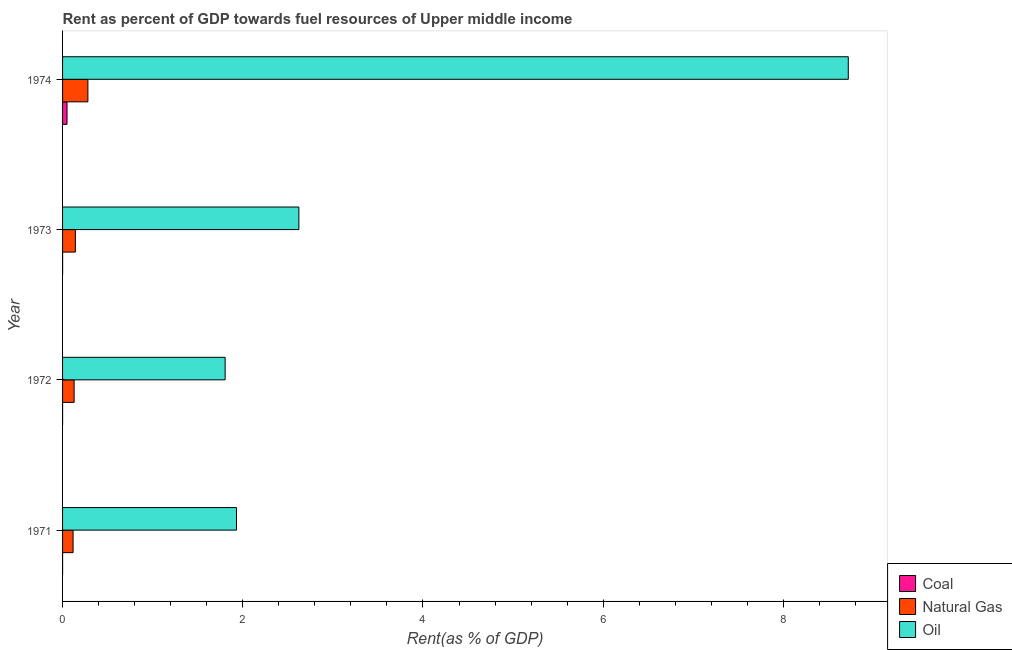How many different coloured bars are there?
Your answer should be very brief. 3. How many groups of bars are there?
Keep it short and to the point. 4. Are the number of bars on each tick of the Y-axis equal?
Provide a succinct answer. Yes. How many bars are there on the 2nd tick from the top?
Provide a short and direct response. 3. How many bars are there on the 4th tick from the bottom?
Offer a terse response. 3. What is the rent towards natural gas in 1974?
Make the answer very short. 0.28. Across all years, what is the maximum rent towards natural gas?
Your answer should be very brief. 0.28. Across all years, what is the minimum rent towards natural gas?
Make the answer very short. 0.12. In which year was the rent towards coal maximum?
Keep it short and to the point. 1974. What is the total rent towards natural gas in the graph?
Your response must be concise. 0.67. What is the difference between the rent towards oil in 1972 and that in 1974?
Give a very brief answer. -6.92. What is the difference between the rent towards oil in 1974 and the rent towards natural gas in 1973?
Your response must be concise. 8.58. What is the average rent towards oil per year?
Provide a short and direct response. 3.77. In the year 1972, what is the difference between the rent towards natural gas and rent towards oil?
Offer a very short reply. -1.68. What is the ratio of the rent towards oil in 1971 to that in 1974?
Your response must be concise. 0.22. Is the rent towards coal in 1972 less than that in 1973?
Give a very brief answer. Yes. Is the difference between the rent towards coal in 1971 and 1972 greater than the difference between the rent towards oil in 1971 and 1972?
Make the answer very short. No. What is the difference between the highest and the second highest rent towards coal?
Keep it short and to the point. 0.05. What is the difference between the highest and the lowest rent towards coal?
Your answer should be compact. 0.05. In how many years, is the rent towards natural gas greater than the average rent towards natural gas taken over all years?
Give a very brief answer. 1. What does the 3rd bar from the top in 1972 represents?
Offer a terse response. Coal. What does the 1st bar from the bottom in 1971 represents?
Your response must be concise. Coal. How many years are there in the graph?
Provide a succinct answer. 4. What is the difference between two consecutive major ticks on the X-axis?
Ensure brevity in your answer.  2. Does the graph contain grids?
Provide a succinct answer. No. Where does the legend appear in the graph?
Provide a short and direct response. Bottom right. How many legend labels are there?
Ensure brevity in your answer.  3. How are the legend labels stacked?
Make the answer very short. Vertical. What is the title of the graph?
Keep it short and to the point. Rent as percent of GDP towards fuel resources of Upper middle income. What is the label or title of the X-axis?
Ensure brevity in your answer.  Rent(as % of GDP). What is the label or title of the Y-axis?
Ensure brevity in your answer.  Year. What is the Rent(as % of GDP) in Coal in 1971?
Your response must be concise. 0. What is the Rent(as % of GDP) of Natural Gas in 1971?
Ensure brevity in your answer.  0.12. What is the Rent(as % of GDP) in Oil in 1971?
Your answer should be very brief. 1.93. What is the Rent(as % of GDP) of Coal in 1972?
Keep it short and to the point. 0. What is the Rent(as % of GDP) in Natural Gas in 1972?
Your response must be concise. 0.13. What is the Rent(as % of GDP) in Oil in 1972?
Your answer should be very brief. 1.8. What is the Rent(as % of GDP) in Coal in 1973?
Provide a short and direct response. 0. What is the Rent(as % of GDP) in Natural Gas in 1973?
Provide a short and direct response. 0.14. What is the Rent(as % of GDP) in Oil in 1973?
Offer a terse response. 2.62. What is the Rent(as % of GDP) of Coal in 1974?
Your response must be concise. 0.05. What is the Rent(as % of GDP) of Natural Gas in 1974?
Provide a succinct answer. 0.28. What is the Rent(as % of GDP) of Oil in 1974?
Your answer should be very brief. 8.72. Across all years, what is the maximum Rent(as % of GDP) in Coal?
Ensure brevity in your answer.  0.05. Across all years, what is the maximum Rent(as % of GDP) of Natural Gas?
Keep it short and to the point. 0.28. Across all years, what is the maximum Rent(as % of GDP) of Oil?
Make the answer very short. 8.72. Across all years, what is the minimum Rent(as % of GDP) in Coal?
Your answer should be compact. 0. Across all years, what is the minimum Rent(as % of GDP) of Natural Gas?
Offer a very short reply. 0.12. Across all years, what is the minimum Rent(as % of GDP) of Oil?
Keep it short and to the point. 1.8. What is the total Rent(as % of GDP) in Coal in the graph?
Offer a terse response. 0.05. What is the total Rent(as % of GDP) in Natural Gas in the graph?
Your answer should be compact. 0.67. What is the total Rent(as % of GDP) of Oil in the graph?
Offer a terse response. 15.08. What is the difference between the Rent(as % of GDP) in Coal in 1971 and that in 1972?
Provide a succinct answer. -0. What is the difference between the Rent(as % of GDP) of Natural Gas in 1971 and that in 1972?
Provide a succinct answer. -0.01. What is the difference between the Rent(as % of GDP) of Oil in 1971 and that in 1972?
Your answer should be very brief. 0.13. What is the difference between the Rent(as % of GDP) in Coal in 1971 and that in 1973?
Your response must be concise. -0. What is the difference between the Rent(as % of GDP) in Natural Gas in 1971 and that in 1973?
Your answer should be very brief. -0.03. What is the difference between the Rent(as % of GDP) of Oil in 1971 and that in 1973?
Provide a succinct answer. -0.69. What is the difference between the Rent(as % of GDP) of Coal in 1971 and that in 1974?
Offer a terse response. -0.05. What is the difference between the Rent(as % of GDP) of Natural Gas in 1971 and that in 1974?
Your answer should be compact. -0.16. What is the difference between the Rent(as % of GDP) of Oil in 1971 and that in 1974?
Provide a short and direct response. -6.79. What is the difference between the Rent(as % of GDP) of Coal in 1972 and that in 1973?
Offer a terse response. -0. What is the difference between the Rent(as % of GDP) in Natural Gas in 1972 and that in 1973?
Provide a succinct answer. -0.01. What is the difference between the Rent(as % of GDP) in Oil in 1972 and that in 1973?
Offer a terse response. -0.82. What is the difference between the Rent(as % of GDP) in Coal in 1972 and that in 1974?
Your response must be concise. -0.05. What is the difference between the Rent(as % of GDP) in Natural Gas in 1972 and that in 1974?
Ensure brevity in your answer.  -0.15. What is the difference between the Rent(as % of GDP) of Oil in 1972 and that in 1974?
Provide a succinct answer. -6.92. What is the difference between the Rent(as % of GDP) in Coal in 1973 and that in 1974?
Make the answer very short. -0.05. What is the difference between the Rent(as % of GDP) of Natural Gas in 1973 and that in 1974?
Ensure brevity in your answer.  -0.14. What is the difference between the Rent(as % of GDP) in Oil in 1973 and that in 1974?
Ensure brevity in your answer.  -6.1. What is the difference between the Rent(as % of GDP) of Coal in 1971 and the Rent(as % of GDP) of Natural Gas in 1972?
Provide a short and direct response. -0.13. What is the difference between the Rent(as % of GDP) of Coal in 1971 and the Rent(as % of GDP) of Oil in 1972?
Your answer should be very brief. -1.8. What is the difference between the Rent(as % of GDP) in Natural Gas in 1971 and the Rent(as % of GDP) in Oil in 1972?
Your answer should be compact. -1.69. What is the difference between the Rent(as % of GDP) of Coal in 1971 and the Rent(as % of GDP) of Natural Gas in 1973?
Make the answer very short. -0.14. What is the difference between the Rent(as % of GDP) in Coal in 1971 and the Rent(as % of GDP) in Oil in 1973?
Offer a terse response. -2.62. What is the difference between the Rent(as % of GDP) in Natural Gas in 1971 and the Rent(as % of GDP) in Oil in 1973?
Your response must be concise. -2.51. What is the difference between the Rent(as % of GDP) in Coal in 1971 and the Rent(as % of GDP) in Natural Gas in 1974?
Your answer should be compact. -0.28. What is the difference between the Rent(as % of GDP) of Coal in 1971 and the Rent(as % of GDP) of Oil in 1974?
Ensure brevity in your answer.  -8.72. What is the difference between the Rent(as % of GDP) of Natural Gas in 1971 and the Rent(as % of GDP) of Oil in 1974?
Give a very brief answer. -8.6. What is the difference between the Rent(as % of GDP) of Coal in 1972 and the Rent(as % of GDP) of Natural Gas in 1973?
Your answer should be compact. -0.14. What is the difference between the Rent(as % of GDP) in Coal in 1972 and the Rent(as % of GDP) in Oil in 1973?
Make the answer very short. -2.62. What is the difference between the Rent(as % of GDP) of Natural Gas in 1972 and the Rent(as % of GDP) of Oil in 1973?
Provide a short and direct response. -2.49. What is the difference between the Rent(as % of GDP) of Coal in 1972 and the Rent(as % of GDP) of Natural Gas in 1974?
Provide a short and direct response. -0.28. What is the difference between the Rent(as % of GDP) in Coal in 1972 and the Rent(as % of GDP) in Oil in 1974?
Provide a succinct answer. -8.72. What is the difference between the Rent(as % of GDP) of Natural Gas in 1972 and the Rent(as % of GDP) of Oil in 1974?
Give a very brief answer. -8.59. What is the difference between the Rent(as % of GDP) in Coal in 1973 and the Rent(as % of GDP) in Natural Gas in 1974?
Your answer should be compact. -0.28. What is the difference between the Rent(as % of GDP) in Coal in 1973 and the Rent(as % of GDP) in Oil in 1974?
Your answer should be very brief. -8.72. What is the difference between the Rent(as % of GDP) in Natural Gas in 1973 and the Rent(as % of GDP) in Oil in 1974?
Offer a terse response. -8.58. What is the average Rent(as % of GDP) of Coal per year?
Your response must be concise. 0.01. What is the average Rent(as % of GDP) of Natural Gas per year?
Make the answer very short. 0.17. What is the average Rent(as % of GDP) in Oil per year?
Provide a succinct answer. 3.77. In the year 1971, what is the difference between the Rent(as % of GDP) of Coal and Rent(as % of GDP) of Natural Gas?
Provide a succinct answer. -0.12. In the year 1971, what is the difference between the Rent(as % of GDP) in Coal and Rent(as % of GDP) in Oil?
Provide a succinct answer. -1.93. In the year 1971, what is the difference between the Rent(as % of GDP) of Natural Gas and Rent(as % of GDP) of Oil?
Your response must be concise. -1.81. In the year 1972, what is the difference between the Rent(as % of GDP) of Coal and Rent(as % of GDP) of Natural Gas?
Provide a short and direct response. -0.13. In the year 1972, what is the difference between the Rent(as % of GDP) in Coal and Rent(as % of GDP) in Oil?
Provide a succinct answer. -1.8. In the year 1972, what is the difference between the Rent(as % of GDP) of Natural Gas and Rent(as % of GDP) of Oil?
Offer a very short reply. -1.68. In the year 1973, what is the difference between the Rent(as % of GDP) of Coal and Rent(as % of GDP) of Natural Gas?
Make the answer very short. -0.14. In the year 1973, what is the difference between the Rent(as % of GDP) in Coal and Rent(as % of GDP) in Oil?
Provide a short and direct response. -2.62. In the year 1973, what is the difference between the Rent(as % of GDP) of Natural Gas and Rent(as % of GDP) of Oil?
Keep it short and to the point. -2.48. In the year 1974, what is the difference between the Rent(as % of GDP) in Coal and Rent(as % of GDP) in Natural Gas?
Keep it short and to the point. -0.23. In the year 1974, what is the difference between the Rent(as % of GDP) in Coal and Rent(as % of GDP) in Oil?
Your response must be concise. -8.67. In the year 1974, what is the difference between the Rent(as % of GDP) of Natural Gas and Rent(as % of GDP) of Oil?
Offer a very short reply. -8.44. What is the ratio of the Rent(as % of GDP) of Coal in 1971 to that in 1972?
Your response must be concise. 0.77. What is the ratio of the Rent(as % of GDP) of Natural Gas in 1971 to that in 1972?
Your answer should be compact. 0.91. What is the ratio of the Rent(as % of GDP) in Oil in 1971 to that in 1972?
Give a very brief answer. 1.07. What is the ratio of the Rent(as % of GDP) of Coal in 1971 to that in 1973?
Keep it short and to the point. 0.51. What is the ratio of the Rent(as % of GDP) in Natural Gas in 1971 to that in 1973?
Give a very brief answer. 0.82. What is the ratio of the Rent(as % of GDP) of Oil in 1971 to that in 1973?
Ensure brevity in your answer.  0.74. What is the ratio of the Rent(as % of GDP) of Coal in 1971 to that in 1974?
Offer a very short reply. 0. What is the ratio of the Rent(as % of GDP) of Natural Gas in 1971 to that in 1974?
Give a very brief answer. 0.42. What is the ratio of the Rent(as % of GDP) in Oil in 1971 to that in 1974?
Give a very brief answer. 0.22. What is the ratio of the Rent(as % of GDP) of Coal in 1972 to that in 1973?
Make the answer very short. 0.66. What is the ratio of the Rent(as % of GDP) of Natural Gas in 1972 to that in 1973?
Offer a very short reply. 0.9. What is the ratio of the Rent(as % of GDP) of Oil in 1972 to that in 1973?
Provide a succinct answer. 0.69. What is the ratio of the Rent(as % of GDP) in Coal in 1972 to that in 1974?
Keep it short and to the point. 0.01. What is the ratio of the Rent(as % of GDP) of Natural Gas in 1972 to that in 1974?
Your answer should be compact. 0.46. What is the ratio of the Rent(as % of GDP) of Oil in 1972 to that in 1974?
Your answer should be compact. 0.21. What is the ratio of the Rent(as % of GDP) in Coal in 1973 to that in 1974?
Provide a short and direct response. 0.01. What is the ratio of the Rent(as % of GDP) of Natural Gas in 1973 to that in 1974?
Provide a short and direct response. 0.51. What is the ratio of the Rent(as % of GDP) of Oil in 1973 to that in 1974?
Provide a succinct answer. 0.3. What is the difference between the highest and the second highest Rent(as % of GDP) in Coal?
Provide a short and direct response. 0.05. What is the difference between the highest and the second highest Rent(as % of GDP) of Natural Gas?
Ensure brevity in your answer.  0.14. What is the difference between the highest and the second highest Rent(as % of GDP) of Oil?
Offer a very short reply. 6.1. What is the difference between the highest and the lowest Rent(as % of GDP) of Coal?
Provide a short and direct response. 0.05. What is the difference between the highest and the lowest Rent(as % of GDP) in Natural Gas?
Your answer should be compact. 0.16. What is the difference between the highest and the lowest Rent(as % of GDP) in Oil?
Your answer should be compact. 6.92. 